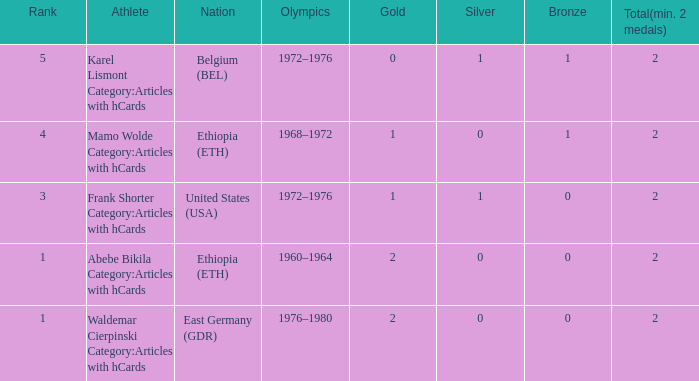What is the least amount of total medals won? 2.0. 